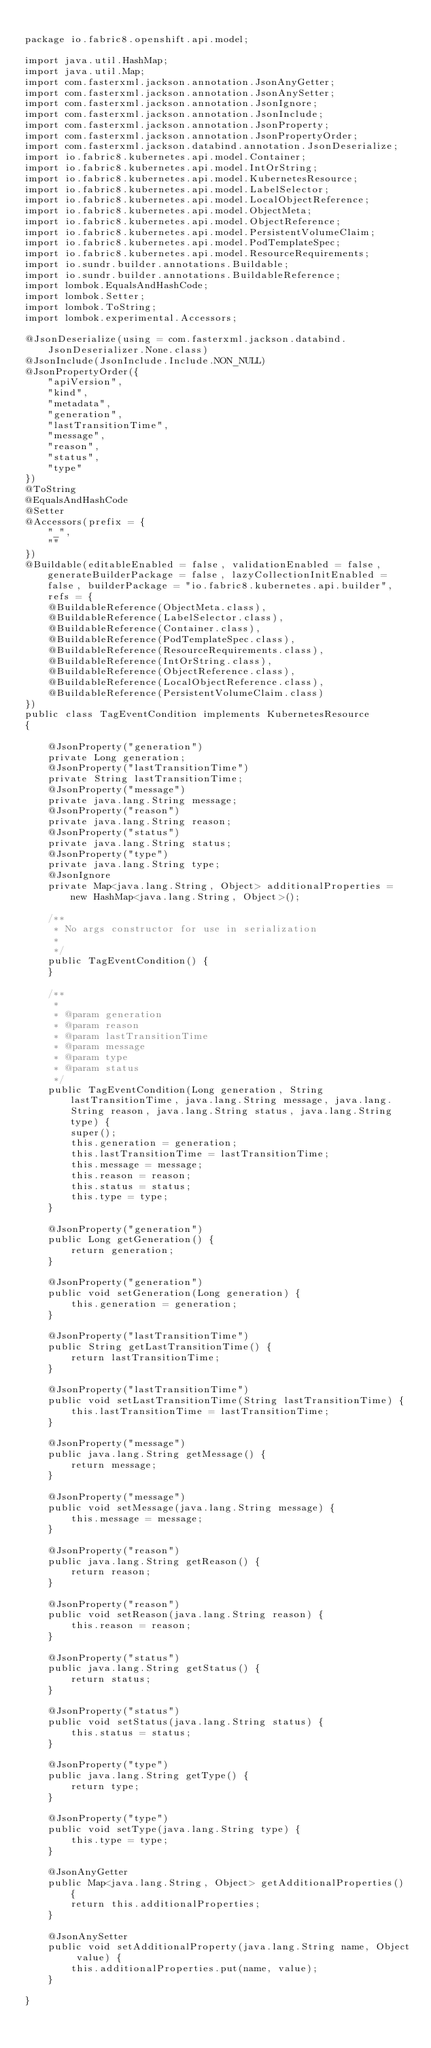<code> <loc_0><loc_0><loc_500><loc_500><_Java_>
package io.fabric8.openshift.api.model;

import java.util.HashMap;
import java.util.Map;
import com.fasterxml.jackson.annotation.JsonAnyGetter;
import com.fasterxml.jackson.annotation.JsonAnySetter;
import com.fasterxml.jackson.annotation.JsonIgnore;
import com.fasterxml.jackson.annotation.JsonInclude;
import com.fasterxml.jackson.annotation.JsonProperty;
import com.fasterxml.jackson.annotation.JsonPropertyOrder;
import com.fasterxml.jackson.databind.annotation.JsonDeserialize;
import io.fabric8.kubernetes.api.model.Container;
import io.fabric8.kubernetes.api.model.IntOrString;
import io.fabric8.kubernetes.api.model.KubernetesResource;
import io.fabric8.kubernetes.api.model.LabelSelector;
import io.fabric8.kubernetes.api.model.LocalObjectReference;
import io.fabric8.kubernetes.api.model.ObjectMeta;
import io.fabric8.kubernetes.api.model.ObjectReference;
import io.fabric8.kubernetes.api.model.PersistentVolumeClaim;
import io.fabric8.kubernetes.api.model.PodTemplateSpec;
import io.fabric8.kubernetes.api.model.ResourceRequirements;
import io.sundr.builder.annotations.Buildable;
import io.sundr.builder.annotations.BuildableReference;
import lombok.EqualsAndHashCode;
import lombok.Setter;
import lombok.ToString;
import lombok.experimental.Accessors;

@JsonDeserialize(using = com.fasterxml.jackson.databind.JsonDeserializer.None.class)
@JsonInclude(JsonInclude.Include.NON_NULL)
@JsonPropertyOrder({
    "apiVersion",
    "kind",
    "metadata",
    "generation",
    "lastTransitionTime",
    "message",
    "reason",
    "status",
    "type"
})
@ToString
@EqualsAndHashCode
@Setter
@Accessors(prefix = {
    "_",
    ""
})
@Buildable(editableEnabled = false, validationEnabled = false, generateBuilderPackage = false, lazyCollectionInitEnabled = false, builderPackage = "io.fabric8.kubernetes.api.builder", refs = {
    @BuildableReference(ObjectMeta.class),
    @BuildableReference(LabelSelector.class),
    @BuildableReference(Container.class),
    @BuildableReference(PodTemplateSpec.class),
    @BuildableReference(ResourceRequirements.class),
    @BuildableReference(IntOrString.class),
    @BuildableReference(ObjectReference.class),
    @BuildableReference(LocalObjectReference.class),
    @BuildableReference(PersistentVolumeClaim.class)
})
public class TagEventCondition implements KubernetesResource
{

    @JsonProperty("generation")
    private Long generation;
    @JsonProperty("lastTransitionTime")
    private String lastTransitionTime;
    @JsonProperty("message")
    private java.lang.String message;
    @JsonProperty("reason")
    private java.lang.String reason;
    @JsonProperty("status")
    private java.lang.String status;
    @JsonProperty("type")
    private java.lang.String type;
    @JsonIgnore
    private Map<java.lang.String, Object> additionalProperties = new HashMap<java.lang.String, Object>();

    /**
     * No args constructor for use in serialization
     * 
     */
    public TagEventCondition() {
    }

    /**
     * 
     * @param generation
     * @param reason
     * @param lastTransitionTime
     * @param message
     * @param type
     * @param status
     */
    public TagEventCondition(Long generation, String lastTransitionTime, java.lang.String message, java.lang.String reason, java.lang.String status, java.lang.String type) {
        super();
        this.generation = generation;
        this.lastTransitionTime = lastTransitionTime;
        this.message = message;
        this.reason = reason;
        this.status = status;
        this.type = type;
    }

    @JsonProperty("generation")
    public Long getGeneration() {
        return generation;
    }

    @JsonProperty("generation")
    public void setGeneration(Long generation) {
        this.generation = generation;
    }

    @JsonProperty("lastTransitionTime")
    public String getLastTransitionTime() {
        return lastTransitionTime;
    }

    @JsonProperty("lastTransitionTime")
    public void setLastTransitionTime(String lastTransitionTime) {
        this.lastTransitionTime = lastTransitionTime;
    }

    @JsonProperty("message")
    public java.lang.String getMessage() {
        return message;
    }

    @JsonProperty("message")
    public void setMessage(java.lang.String message) {
        this.message = message;
    }

    @JsonProperty("reason")
    public java.lang.String getReason() {
        return reason;
    }

    @JsonProperty("reason")
    public void setReason(java.lang.String reason) {
        this.reason = reason;
    }

    @JsonProperty("status")
    public java.lang.String getStatus() {
        return status;
    }

    @JsonProperty("status")
    public void setStatus(java.lang.String status) {
        this.status = status;
    }

    @JsonProperty("type")
    public java.lang.String getType() {
        return type;
    }

    @JsonProperty("type")
    public void setType(java.lang.String type) {
        this.type = type;
    }

    @JsonAnyGetter
    public Map<java.lang.String, Object> getAdditionalProperties() {
        return this.additionalProperties;
    }

    @JsonAnySetter
    public void setAdditionalProperty(java.lang.String name, Object value) {
        this.additionalProperties.put(name, value);
    }

}
</code> 